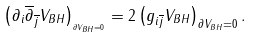<formula> <loc_0><loc_0><loc_500><loc_500>\left ( \partial _ { i } \overline { \partial } _ { \overline { j } } V _ { B H } \right ) _ { _ { \partial V _ { B H } = 0 } } = 2 \left ( g _ { i \overline { j } } V _ { B H } \right ) _ { \partial V _ { B H } = 0 } .</formula> 